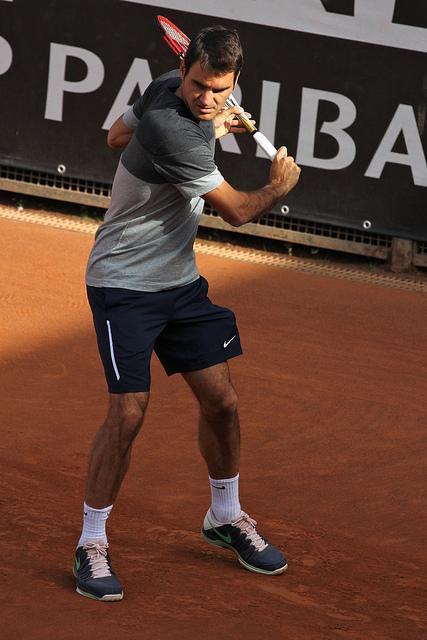How many boats are on the water?
Give a very brief answer. 0. 